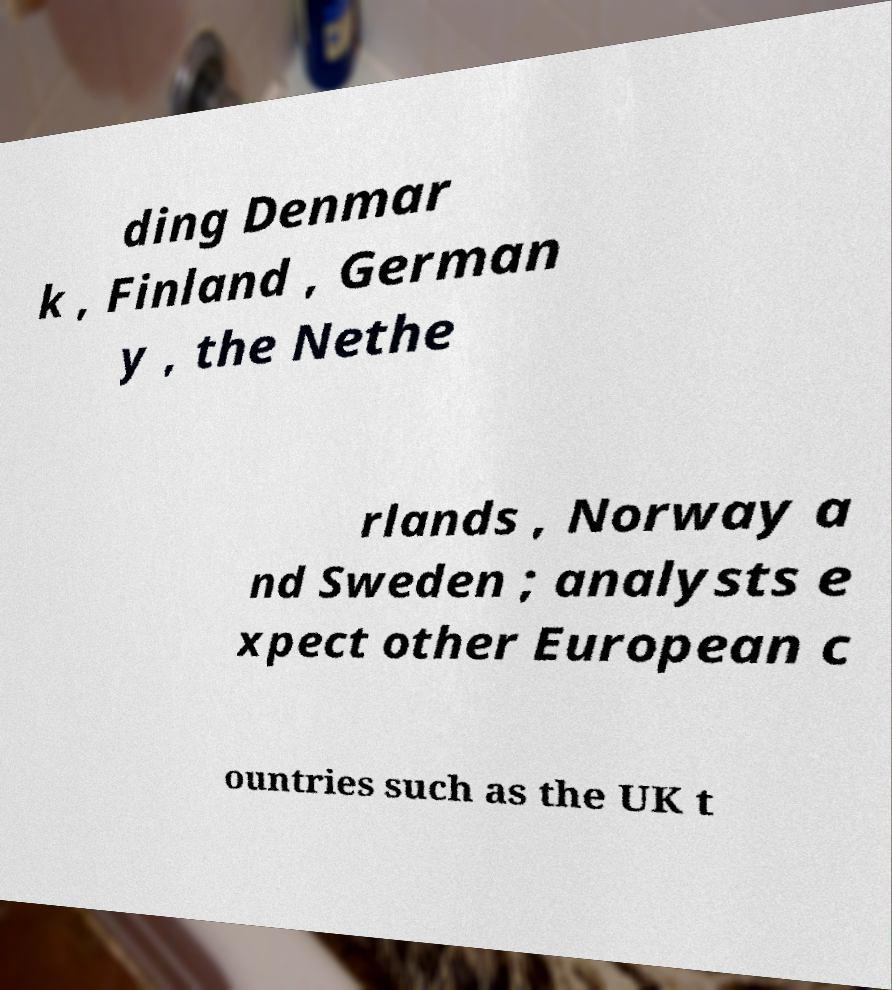Can you read and provide the text displayed in the image?This photo seems to have some interesting text. Can you extract and type it out for me? ding Denmar k , Finland , German y , the Nethe rlands , Norway a nd Sweden ; analysts e xpect other European c ountries such as the UK t 